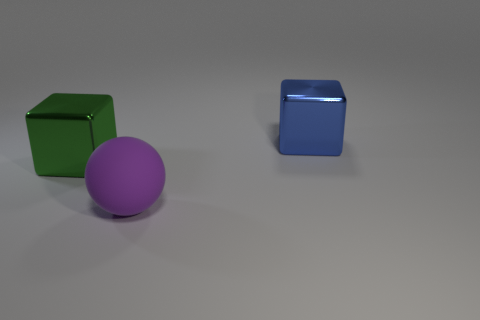There is a large metallic cube right of the large purple thing; is it the same color as the large object that is to the left of the purple rubber object?
Offer a very short reply. No. Is there anything else of the same color as the rubber sphere?
Your response must be concise. No. Is the number of big things that are on the right side of the sphere less than the number of purple rubber balls?
Provide a succinct answer. No. What number of small purple objects are there?
Offer a very short reply. 0. There is a purple rubber object; is it the same shape as the object that is to the right of the big purple rubber ball?
Ensure brevity in your answer.  No. Is the number of big matte things in front of the large purple object less than the number of green metal cubes that are right of the blue object?
Offer a terse response. No. Is there anything else that is the same shape as the blue shiny object?
Offer a very short reply. Yes. Is the shape of the purple thing the same as the big blue metal thing?
Give a very brief answer. No. Is there any other thing that is the same material as the large blue cube?
Offer a very short reply. Yes. The blue metal block is what size?
Provide a short and direct response. Large. 